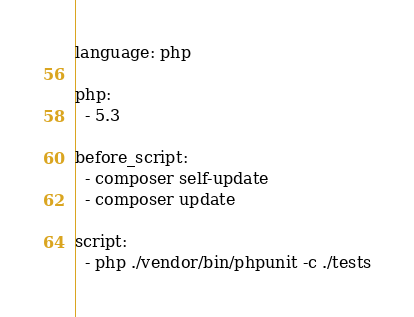Convert code to text. <code><loc_0><loc_0><loc_500><loc_500><_YAML_>language: php

php:
  - 5.3

before_script:
  - composer self-update
  - composer update

script:
  - php ./vendor/bin/phpunit -c ./tests

</code> 